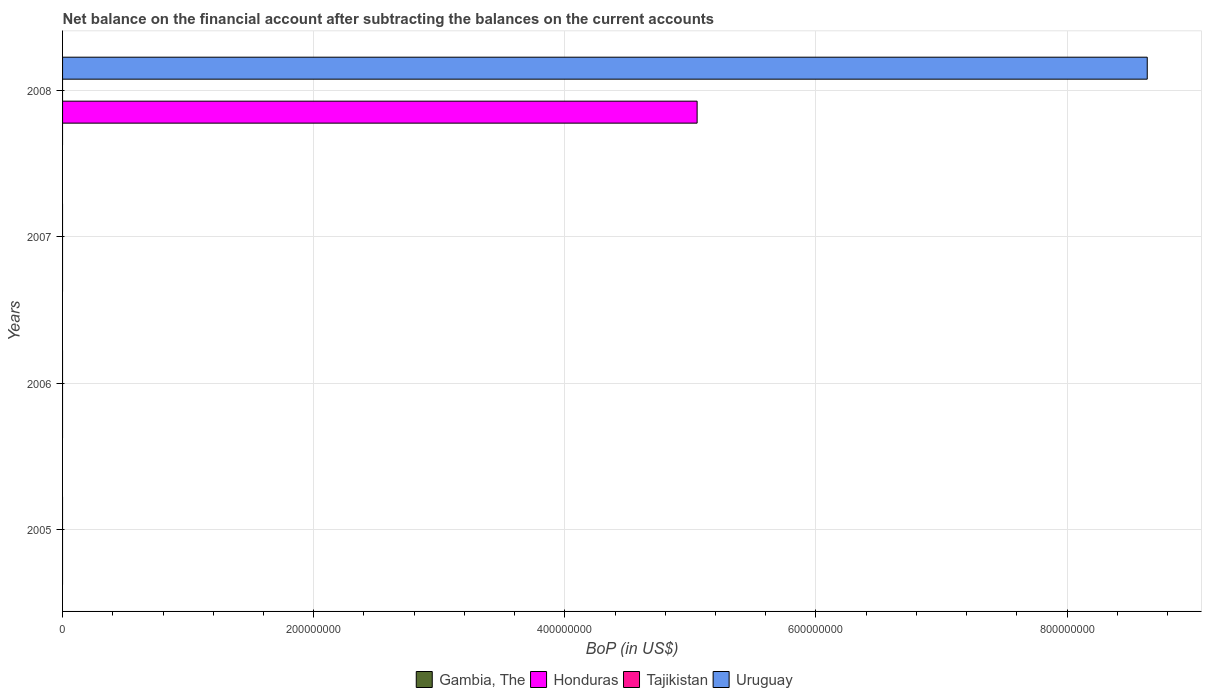How many different coloured bars are there?
Your answer should be very brief. 2. In how many cases, is the number of bars for a given year not equal to the number of legend labels?
Your answer should be very brief. 4. What is the Balance of Payments in Honduras in 2007?
Your response must be concise. 0. Across all years, what is the maximum Balance of Payments in Uruguay?
Your answer should be very brief. 8.64e+08. Across all years, what is the minimum Balance of Payments in Honduras?
Your answer should be compact. 0. What is the total Balance of Payments in Uruguay in the graph?
Offer a terse response. 8.64e+08. What is the difference between the Balance of Payments in Gambia, The in 2006 and the Balance of Payments in Uruguay in 2008?
Give a very brief answer. -8.64e+08. What is the average Balance of Payments in Gambia, The per year?
Your response must be concise. 0. In how many years, is the Balance of Payments in Honduras greater than 800000000 US$?
Offer a terse response. 0. What is the difference between the highest and the lowest Balance of Payments in Uruguay?
Provide a short and direct response. 8.64e+08. Is it the case that in every year, the sum of the Balance of Payments in Gambia, The and Balance of Payments in Tajikistan is greater than the Balance of Payments in Honduras?
Make the answer very short. No. How many years are there in the graph?
Offer a terse response. 4. Where does the legend appear in the graph?
Your answer should be very brief. Bottom center. How many legend labels are there?
Offer a terse response. 4. What is the title of the graph?
Provide a short and direct response. Net balance on the financial account after subtracting the balances on the current accounts. What is the label or title of the X-axis?
Ensure brevity in your answer.  BoP (in US$). What is the label or title of the Y-axis?
Your answer should be very brief. Years. What is the BoP (in US$) of Gambia, The in 2005?
Your answer should be compact. 0. What is the BoP (in US$) in Honduras in 2005?
Give a very brief answer. 0. What is the BoP (in US$) of Tajikistan in 2005?
Provide a short and direct response. 0. What is the BoP (in US$) in Tajikistan in 2006?
Ensure brevity in your answer.  0. What is the BoP (in US$) in Uruguay in 2006?
Your response must be concise. 0. What is the BoP (in US$) of Gambia, The in 2007?
Give a very brief answer. 0. What is the BoP (in US$) in Honduras in 2007?
Offer a very short reply. 0. What is the BoP (in US$) in Gambia, The in 2008?
Ensure brevity in your answer.  0. What is the BoP (in US$) of Honduras in 2008?
Give a very brief answer. 5.05e+08. What is the BoP (in US$) in Tajikistan in 2008?
Make the answer very short. 0. What is the BoP (in US$) in Uruguay in 2008?
Offer a very short reply. 8.64e+08. Across all years, what is the maximum BoP (in US$) in Honduras?
Offer a terse response. 5.05e+08. Across all years, what is the maximum BoP (in US$) in Uruguay?
Make the answer very short. 8.64e+08. Across all years, what is the minimum BoP (in US$) of Honduras?
Provide a succinct answer. 0. Across all years, what is the minimum BoP (in US$) in Uruguay?
Your answer should be compact. 0. What is the total BoP (in US$) of Honduras in the graph?
Offer a terse response. 5.05e+08. What is the total BoP (in US$) in Uruguay in the graph?
Ensure brevity in your answer.  8.64e+08. What is the average BoP (in US$) in Honduras per year?
Keep it short and to the point. 1.26e+08. What is the average BoP (in US$) of Uruguay per year?
Give a very brief answer. 2.16e+08. In the year 2008, what is the difference between the BoP (in US$) in Honduras and BoP (in US$) in Uruguay?
Offer a terse response. -3.58e+08. What is the difference between the highest and the lowest BoP (in US$) of Honduras?
Give a very brief answer. 5.05e+08. What is the difference between the highest and the lowest BoP (in US$) in Uruguay?
Your response must be concise. 8.64e+08. 